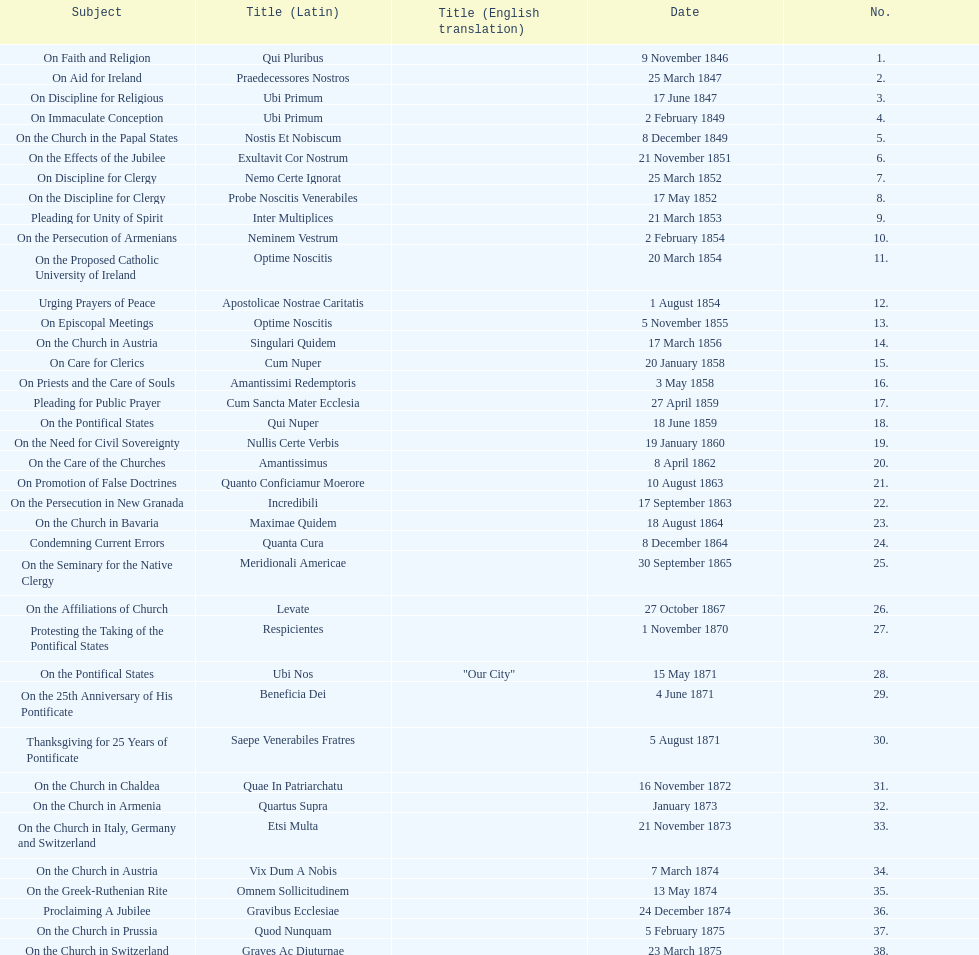Total number of encyclicals on churches . 11. Parse the table in full. {'header': ['Subject', 'Title (Latin)', 'Title (English translation)', 'Date', 'No.'], 'rows': [['On Faith and Religion', 'Qui Pluribus', '', '9 November 1846', '1.'], ['On Aid for Ireland', 'Praedecessores Nostros', '', '25 March 1847', '2.'], ['On Discipline for Religious', 'Ubi Primum', '', '17 June 1847', '3.'], ['On Immaculate Conception', 'Ubi Primum', '', '2 February 1849', '4.'], ['On the Church in the Papal States', 'Nostis Et Nobiscum', '', '8 December 1849', '5.'], ['On the Effects of the Jubilee', 'Exultavit Cor Nostrum', '', '21 November 1851', '6.'], ['On Discipline for Clergy', 'Nemo Certe Ignorat', '', '25 March 1852', '7.'], ['On the Discipline for Clergy', 'Probe Noscitis Venerabiles', '', '17 May 1852', '8.'], ['Pleading for Unity of Spirit', 'Inter Multiplices', '', '21 March 1853', '9.'], ['On the Persecution of Armenians', 'Neminem Vestrum', '', '2 February 1854', '10.'], ['On the Proposed Catholic University of Ireland', 'Optime Noscitis', '', '20 March 1854', '11.'], ['Urging Prayers of Peace', 'Apostolicae Nostrae Caritatis', '', '1 August 1854', '12.'], ['On Episcopal Meetings', 'Optime Noscitis', '', '5 November 1855', '13.'], ['On the Church in Austria', 'Singulari Quidem', '', '17 March 1856', '14.'], ['On Care for Clerics', 'Cum Nuper', '', '20 January 1858', '15.'], ['On Priests and the Care of Souls', 'Amantissimi Redemptoris', '', '3 May 1858', '16.'], ['Pleading for Public Prayer', 'Cum Sancta Mater Ecclesia', '', '27 April 1859', '17.'], ['On the Pontifical States', 'Qui Nuper', '', '18 June 1859', '18.'], ['On the Need for Civil Sovereignty', 'Nullis Certe Verbis', '', '19 January 1860', '19.'], ['On the Care of the Churches', 'Amantissimus', '', '8 April 1862', '20.'], ['On Promotion of False Doctrines', 'Quanto Conficiamur Moerore', '', '10 August 1863', '21.'], ['On the Persecution in New Granada', 'Incredibili', '', '17 September 1863', '22.'], ['On the Church in Bavaria', 'Maximae Quidem', '', '18 August 1864', '23.'], ['Condemning Current Errors', 'Quanta Cura', '', '8 December 1864', '24.'], ['On the Seminary for the Native Clergy', 'Meridionali Americae', '', '30 September 1865', '25.'], ['On the Affiliations of Church', 'Levate', '', '27 October 1867', '26.'], ['Protesting the Taking of the Pontifical States', 'Respicientes', '', '1 November 1870', '27.'], ['On the Pontifical States', 'Ubi Nos', '"Our City"', '15 May 1871', '28.'], ['On the 25th Anniversary of His Pontificate', 'Beneficia Dei', '', '4 June 1871', '29.'], ['Thanksgiving for 25 Years of Pontificate', 'Saepe Venerabiles Fratres', '', '5 August 1871', '30.'], ['On the Church in Chaldea', 'Quae In Patriarchatu', '', '16 November 1872', '31.'], ['On the Church in Armenia', 'Quartus Supra', '', 'January 1873', '32.'], ['On the Church in Italy, Germany and Switzerland', 'Etsi Multa', '', '21 November 1873', '33.'], ['On the Church in Austria', 'Vix Dum A Nobis', '', '7 March 1874', '34.'], ['On the Greek-Ruthenian Rite', 'Omnem Sollicitudinem', '', '13 May 1874', '35.'], ['Proclaiming A Jubilee', 'Gravibus Ecclesiae', '', '24 December 1874', '36.'], ['On the Church in Prussia', 'Quod Nunquam', '', '5 February 1875', '37.'], ['On the Church in Switzerland', 'Graves Ac Diuturnae', '', '23 March 1875', '38.']]} 